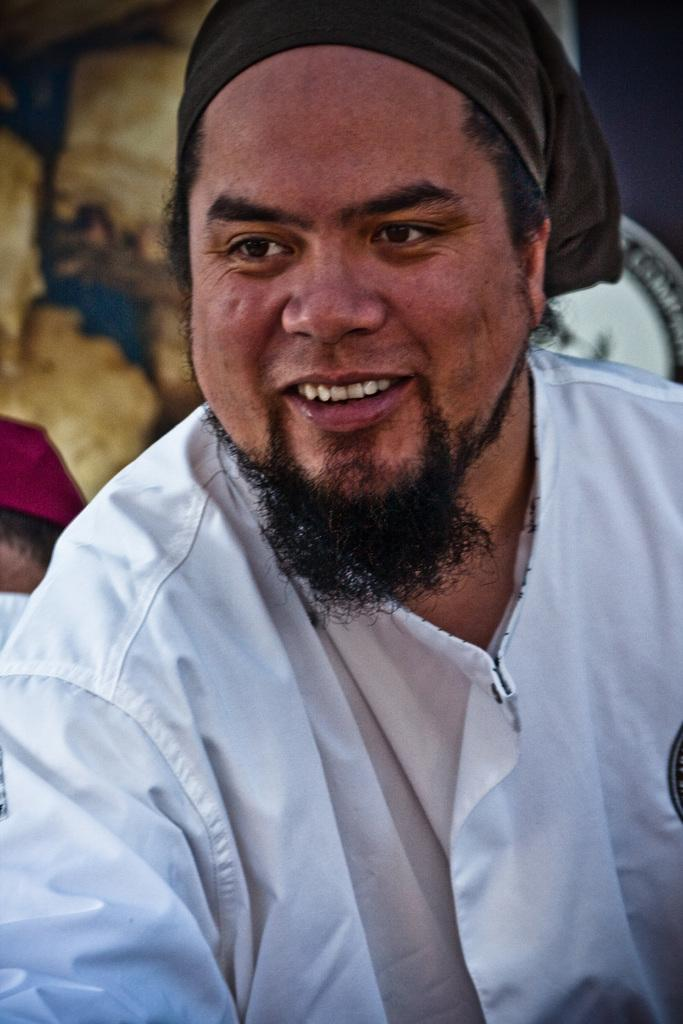What is the main subject of the image? There is a person in the image. What is the person wearing? The person is wearing a white shirt. What expression does the person have? The person is smiling. What can be seen in the background of the image? There is a wall in the background of the image. What degree does the robin have in the image? There is no robin present in the image, so it is not possible to determine the degree of any robin. 